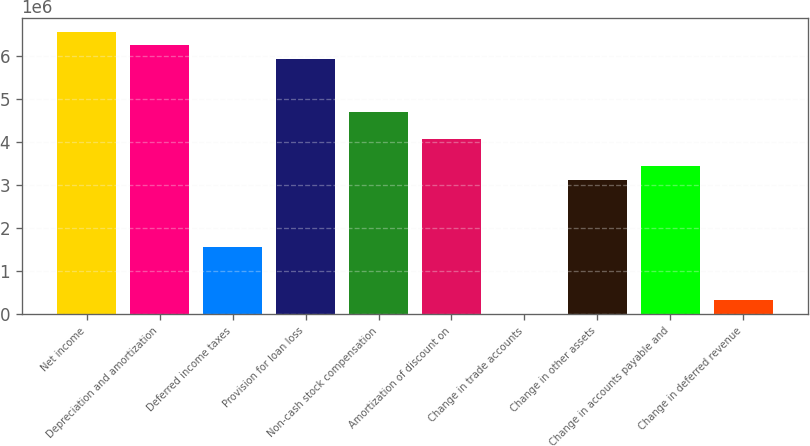<chart> <loc_0><loc_0><loc_500><loc_500><bar_chart><fcel>Net income<fcel>Depreciation and amortization<fcel>Deferred income taxes<fcel>Provision for loan loss<fcel>Non-cash stock compensation<fcel>Amortization of discount on<fcel>Change in trade accounts<fcel>Change in other assets<fcel>Change in accounts payable and<fcel>Change in deferred revenue<nl><fcel>6.55802e+06<fcel>6.24584e+06<fcel>1.56308e+06<fcel>5.93365e+06<fcel>4.68492e+06<fcel>4.06055e+06<fcel>2162<fcel>3.124e+06<fcel>3.43618e+06<fcel>314346<nl></chart> 